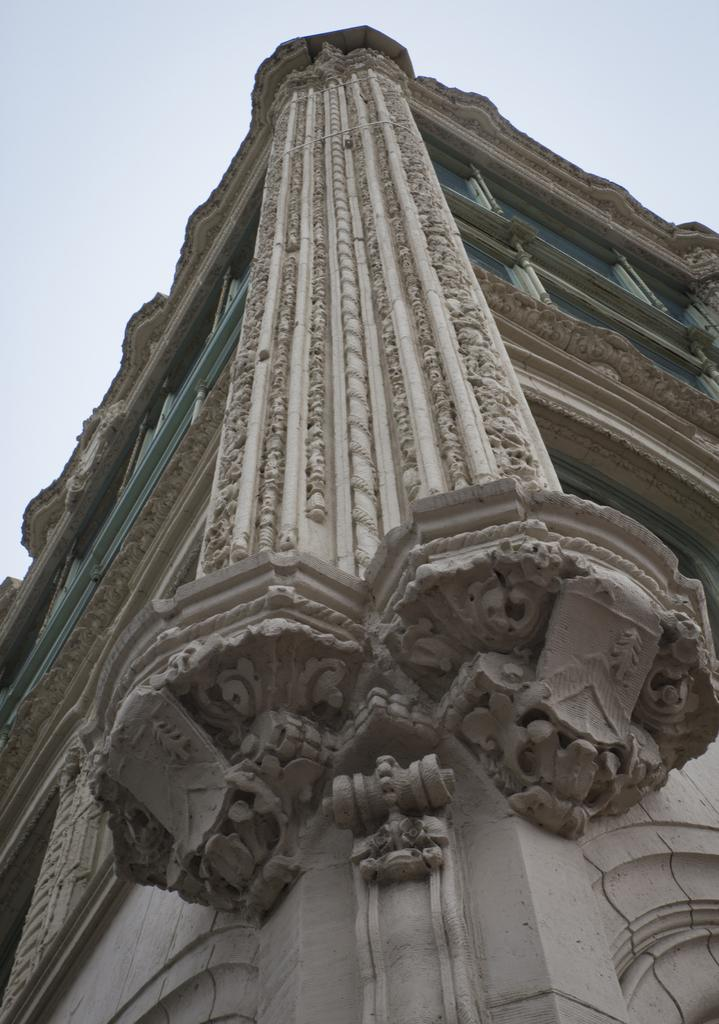What is the main subject in the center of the image? There is a building in the center of the image. What can be seen above the building in the image? The sky is visible at the top of the image. How many eggs are present on the roof of the building in the image? There is no mention of eggs in the image, and therefore no such objects can be observed. 